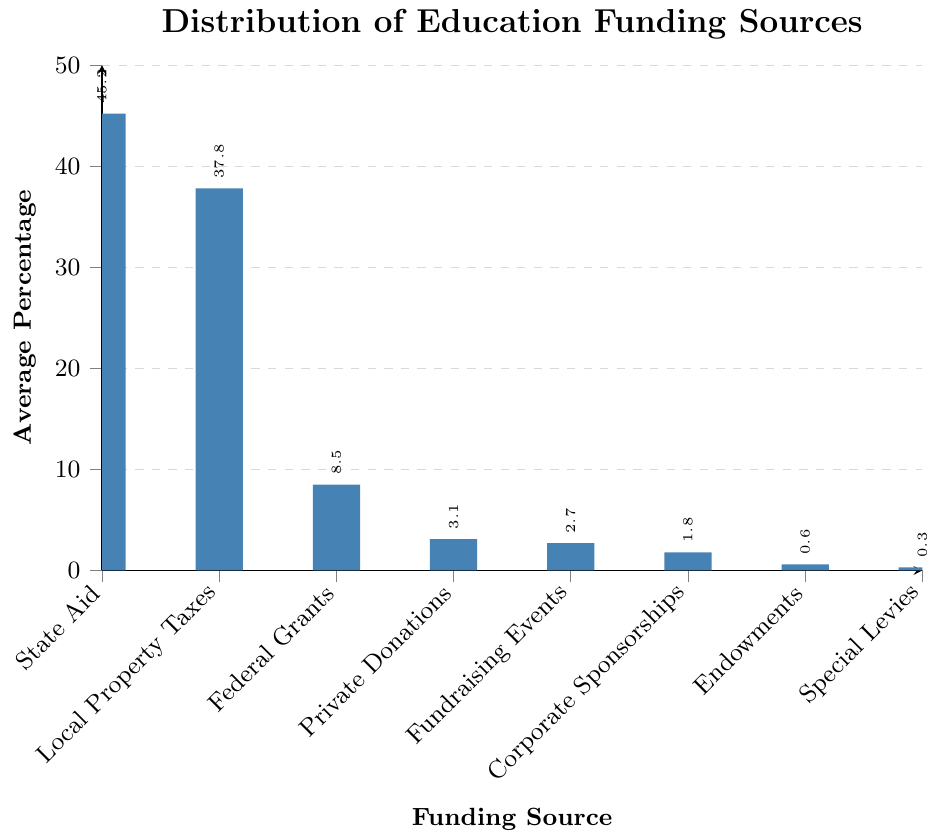What is the funding source with the highest average percentage? The bar representing each funding source's average percentage is visible. The tallest bar corresponds to "State Aid," with an average percentage of 45.2.
Answer: State Aid Which funding source contributes the least to average education funding? On the bar chart, the shortest bar represents the funding source with the least contribution. "Special Levies" has the shortest bar with an average percentage of 0.3.
Answer: Special Levies What is the difference in average percentage between State Aid and Local Property Taxes? From the chart, State Aid has an average percentage of 45.2, and Local Property Taxes have 37.8. The difference is calculated as 45.2 - 37.8.
Answer: 7.4 How do Federal Grants compare to Private Donations in terms of average percentage? Observing the heights of the bars, Federal Grants have an average percentage of 8.5, and Private Donations have 3.1. Federal Grants have a higher average percentage than Private Donations.
Answer: Federal Grants have a higher average percentage What is the total contribution of Local Property Taxes, Federal Grants, and Corporate Sponsorships? The average percentages are summed: 37.8 (Local Property Taxes) + 8.5 (Federal Grants) + 1.8 (Corporate Sponsorships). The total is calculated as 37.8 + 8.5 + 1.8.
Answer: 48.1 If Endowments and Special Levies combined, what would their average percentage be? Adding the average percentages of Endowments (0.6) and Special Levies (0.3) gives the combined value of 0.6 + 0.3.
Answer: 0.9 What is the visual distinction between the bars representing Federal Grants and Fundraising Events? The heights of the bars indicate their values. The bar for Federal Grants is taller (8.5) compared to Fundraising Events (2.7), showing that Federal Grants have a higher average percentage.
Answer: Federal Grants bar is taller Which funding source appears third in percentage order, and what is its value? The chart shows bars in descending order. The third tallest bar corresponds to "Federal Grants" with an average percentage of 8.5.
Answer: Federal Grants, 8.5 How much more do Local Property Taxes contribute than Corporate Sponsorships? The average percentage for Local Property Taxes is 37.8 and for Corporate Sponsorships is 1.8. Subtracting these values gives 37.8 - 1.8.
Answer: 36.0 What would be the average education funding if Private Donations and Fundraising Events were combined into a single category? Summing the average percentages: 3.1 (Private Donations) + 2.7 (Fundraising Events) equals 3.1 + 2.7.
Answer: 5.8 